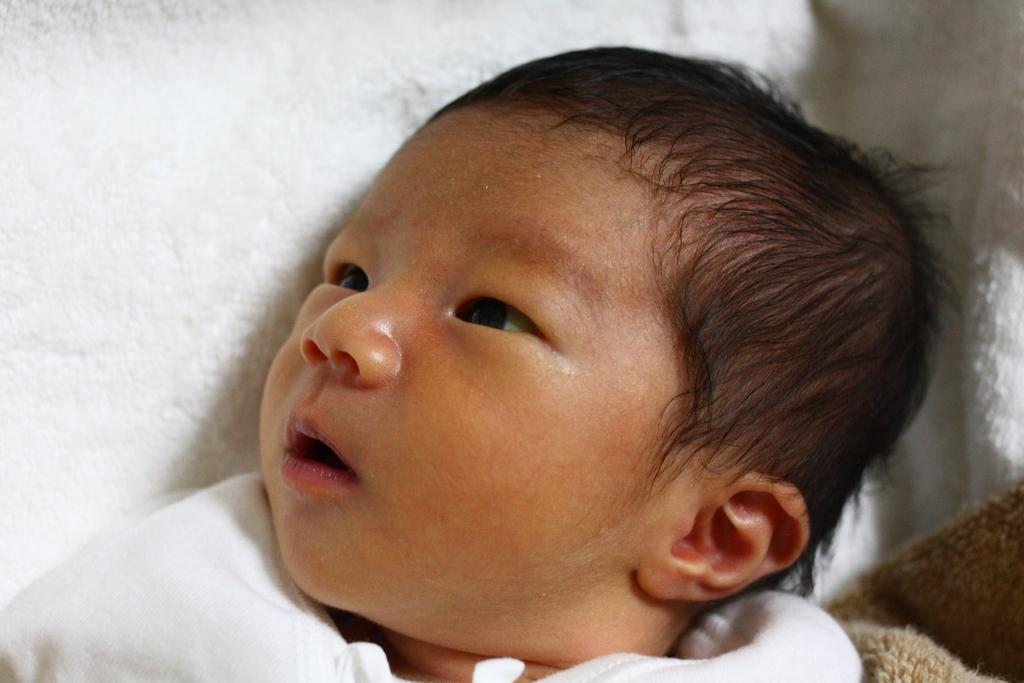What is the main subject of the image? There is a baby in the image. What is the baby lying on? The baby is lying on a white cloth. What type of flowers are present in the image? There are no flowers present in the image; it features a baby lying on a white cloth. In which direction is the baby facing in the image? The provided facts do not mention the direction the baby is facing, so it cannot be determined from the image. 